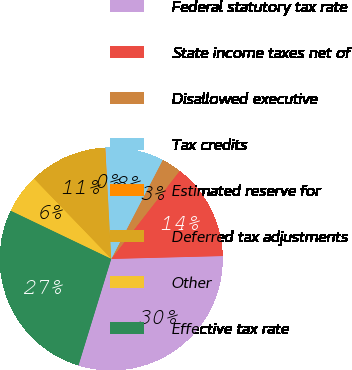<chart> <loc_0><loc_0><loc_500><loc_500><pie_chart><fcel>Federal statutory tax rate<fcel>State income taxes net of<fcel>Disallowed executive<fcel>Tax credits<fcel>Estimated reserve for<fcel>Deferred tax adjustments<fcel>Other<fcel>Effective tax rate<nl><fcel>30.16%<fcel>14.08%<fcel>2.88%<fcel>8.48%<fcel>0.08%<fcel>11.28%<fcel>5.68%<fcel>27.36%<nl></chart> 